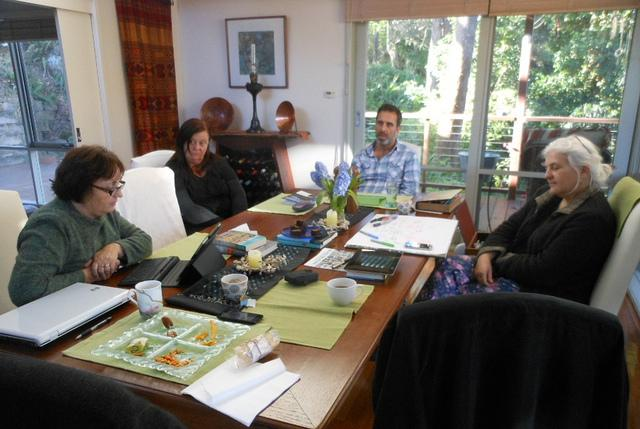What kind of gathering is this?

Choices:
A) business
B) religious
C) social
D) family business 